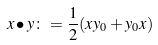Convert formula to latex. <formula><loc_0><loc_0><loc_500><loc_500>x \bullet y \colon = \frac { 1 } { 2 } ( x y _ { 0 } + y _ { 0 } x )</formula> 